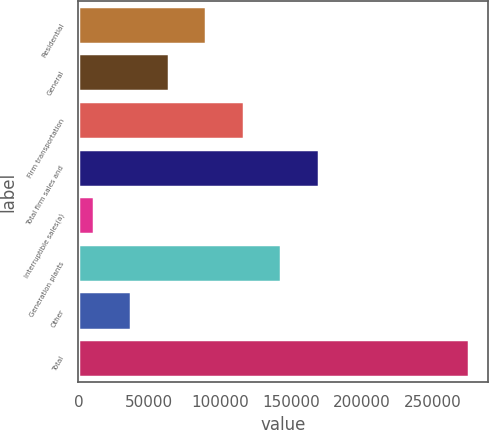Convert chart. <chart><loc_0><loc_0><loc_500><loc_500><bar_chart><fcel>Residential<fcel>General<fcel>Firm transportation<fcel>Total firm sales and<fcel>Interruptible sales(a)<fcel>Generation plants<fcel>Other<fcel>Total<nl><fcel>90162.1<fcel>63741.4<fcel>116583<fcel>169424<fcel>10900<fcel>143004<fcel>37320.7<fcel>275107<nl></chart> 